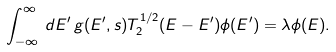Convert formula to latex. <formula><loc_0><loc_0><loc_500><loc_500>\int _ { - \infty } ^ { \infty } \, d E ^ { \prime } \, g ( E ^ { \prime } , s ) T _ { 2 } ^ { 1 / 2 } ( E - E ^ { \prime } ) \phi ( E ^ { \prime } ) = \lambda \phi ( E ) .</formula> 